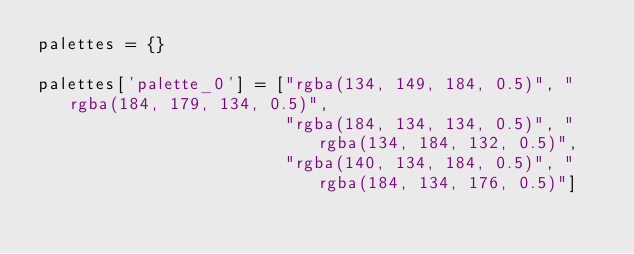Convert code to text. <code><loc_0><loc_0><loc_500><loc_500><_Python_>palettes = {}

palettes['palette_0'] = ["rgba(134, 149, 184, 0.5)", "rgba(184, 179, 134, 0.5)",
                         "rgba(184, 134, 134, 0.5)", "rgba(134, 184, 132, 0.5)",
                         "rgba(140, 134, 184, 0.5)", "rgba(184, 134, 176, 0.5)"]
</code> 